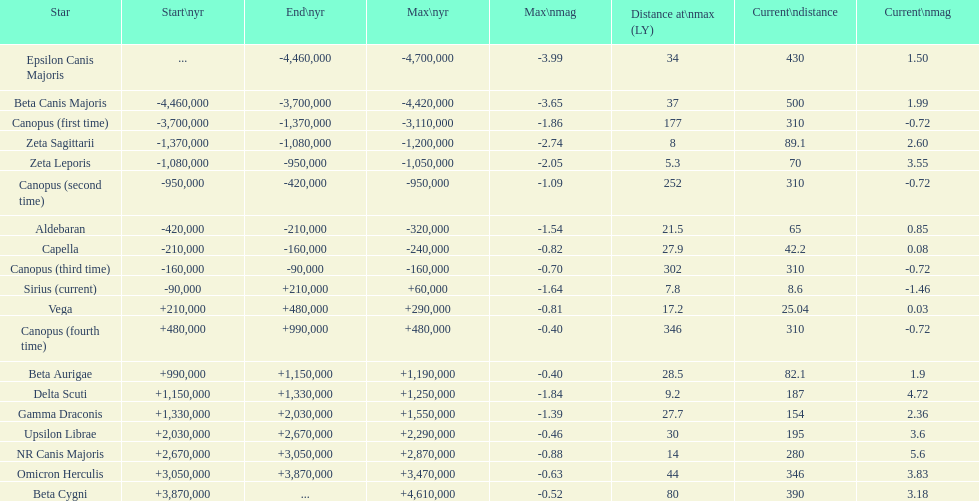Would you be able to parse every entry in this table? {'header': ['Star', 'Start\\nyr', 'End\\nyr', 'Max\\nyr', 'Max\\nmag', 'Distance at\\nmax (LY)', 'Current\\ndistance', 'Current\\nmag'], 'rows': [['Epsilon Canis Majoris', '...', '-4,460,000', '-4,700,000', '-3.99', '34', '430', '1.50'], ['Beta Canis Majoris', '-4,460,000', '-3,700,000', '-4,420,000', '-3.65', '37', '500', '1.99'], ['Canopus (first time)', '-3,700,000', '-1,370,000', '-3,110,000', '-1.86', '177', '310', '-0.72'], ['Zeta Sagittarii', '-1,370,000', '-1,080,000', '-1,200,000', '-2.74', '8', '89.1', '2.60'], ['Zeta Leporis', '-1,080,000', '-950,000', '-1,050,000', '-2.05', '5.3', '70', '3.55'], ['Canopus (second time)', '-950,000', '-420,000', '-950,000', '-1.09', '252', '310', '-0.72'], ['Aldebaran', '-420,000', '-210,000', '-320,000', '-1.54', '21.5', '65', '0.85'], ['Capella', '-210,000', '-160,000', '-240,000', '-0.82', '27.9', '42.2', '0.08'], ['Canopus (third time)', '-160,000', '-90,000', '-160,000', '-0.70', '302', '310', '-0.72'], ['Sirius (current)', '-90,000', '+210,000', '+60,000', '-1.64', '7.8', '8.6', '-1.46'], ['Vega', '+210,000', '+480,000', '+290,000', '-0.81', '17.2', '25.04', '0.03'], ['Canopus (fourth time)', '+480,000', '+990,000', '+480,000', '-0.40', '346', '310', '-0.72'], ['Beta Aurigae', '+990,000', '+1,150,000', '+1,190,000', '-0.40', '28.5', '82.1', '1.9'], ['Delta Scuti', '+1,150,000', '+1,330,000', '+1,250,000', '-1.84', '9.2', '187', '4.72'], ['Gamma Draconis', '+1,330,000', '+2,030,000', '+1,550,000', '-1.39', '27.7', '154', '2.36'], ['Upsilon Librae', '+2,030,000', '+2,670,000', '+2,290,000', '-0.46', '30', '195', '3.6'], ['NR Canis Majoris', '+2,670,000', '+3,050,000', '+2,870,000', '-0.88', '14', '280', '5.6'], ['Omicron Herculis', '+3,050,000', '+3,870,000', '+3,470,000', '-0.63', '44', '346', '3.83'], ['Beta Cygni', '+3,870,000', '...', '+4,610,000', '-0.52', '80', '390', '3.18']]} How much farther (in ly) is epsilon canis majoris than zeta sagittarii? 26. 